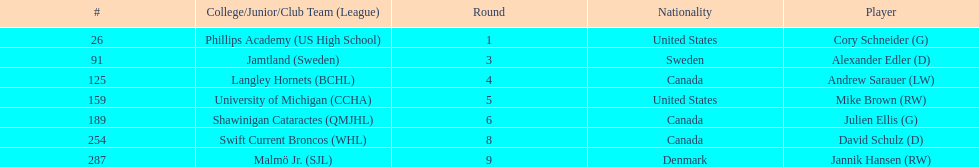The first round not to have a draft pick. 2. 